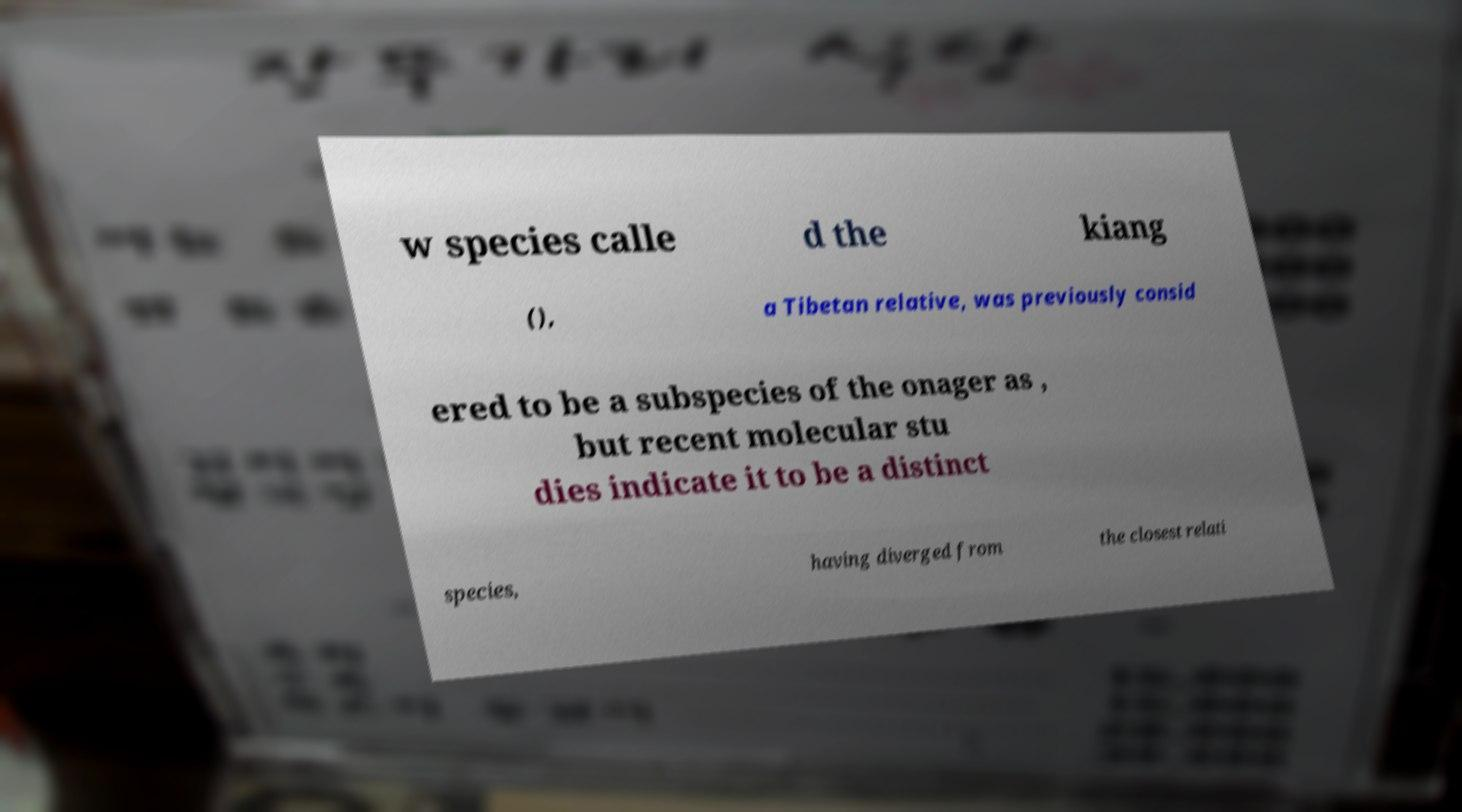Could you extract and type out the text from this image? w species calle d the kiang (), a Tibetan relative, was previously consid ered to be a subspecies of the onager as , but recent molecular stu dies indicate it to be a distinct species, having diverged from the closest relati 